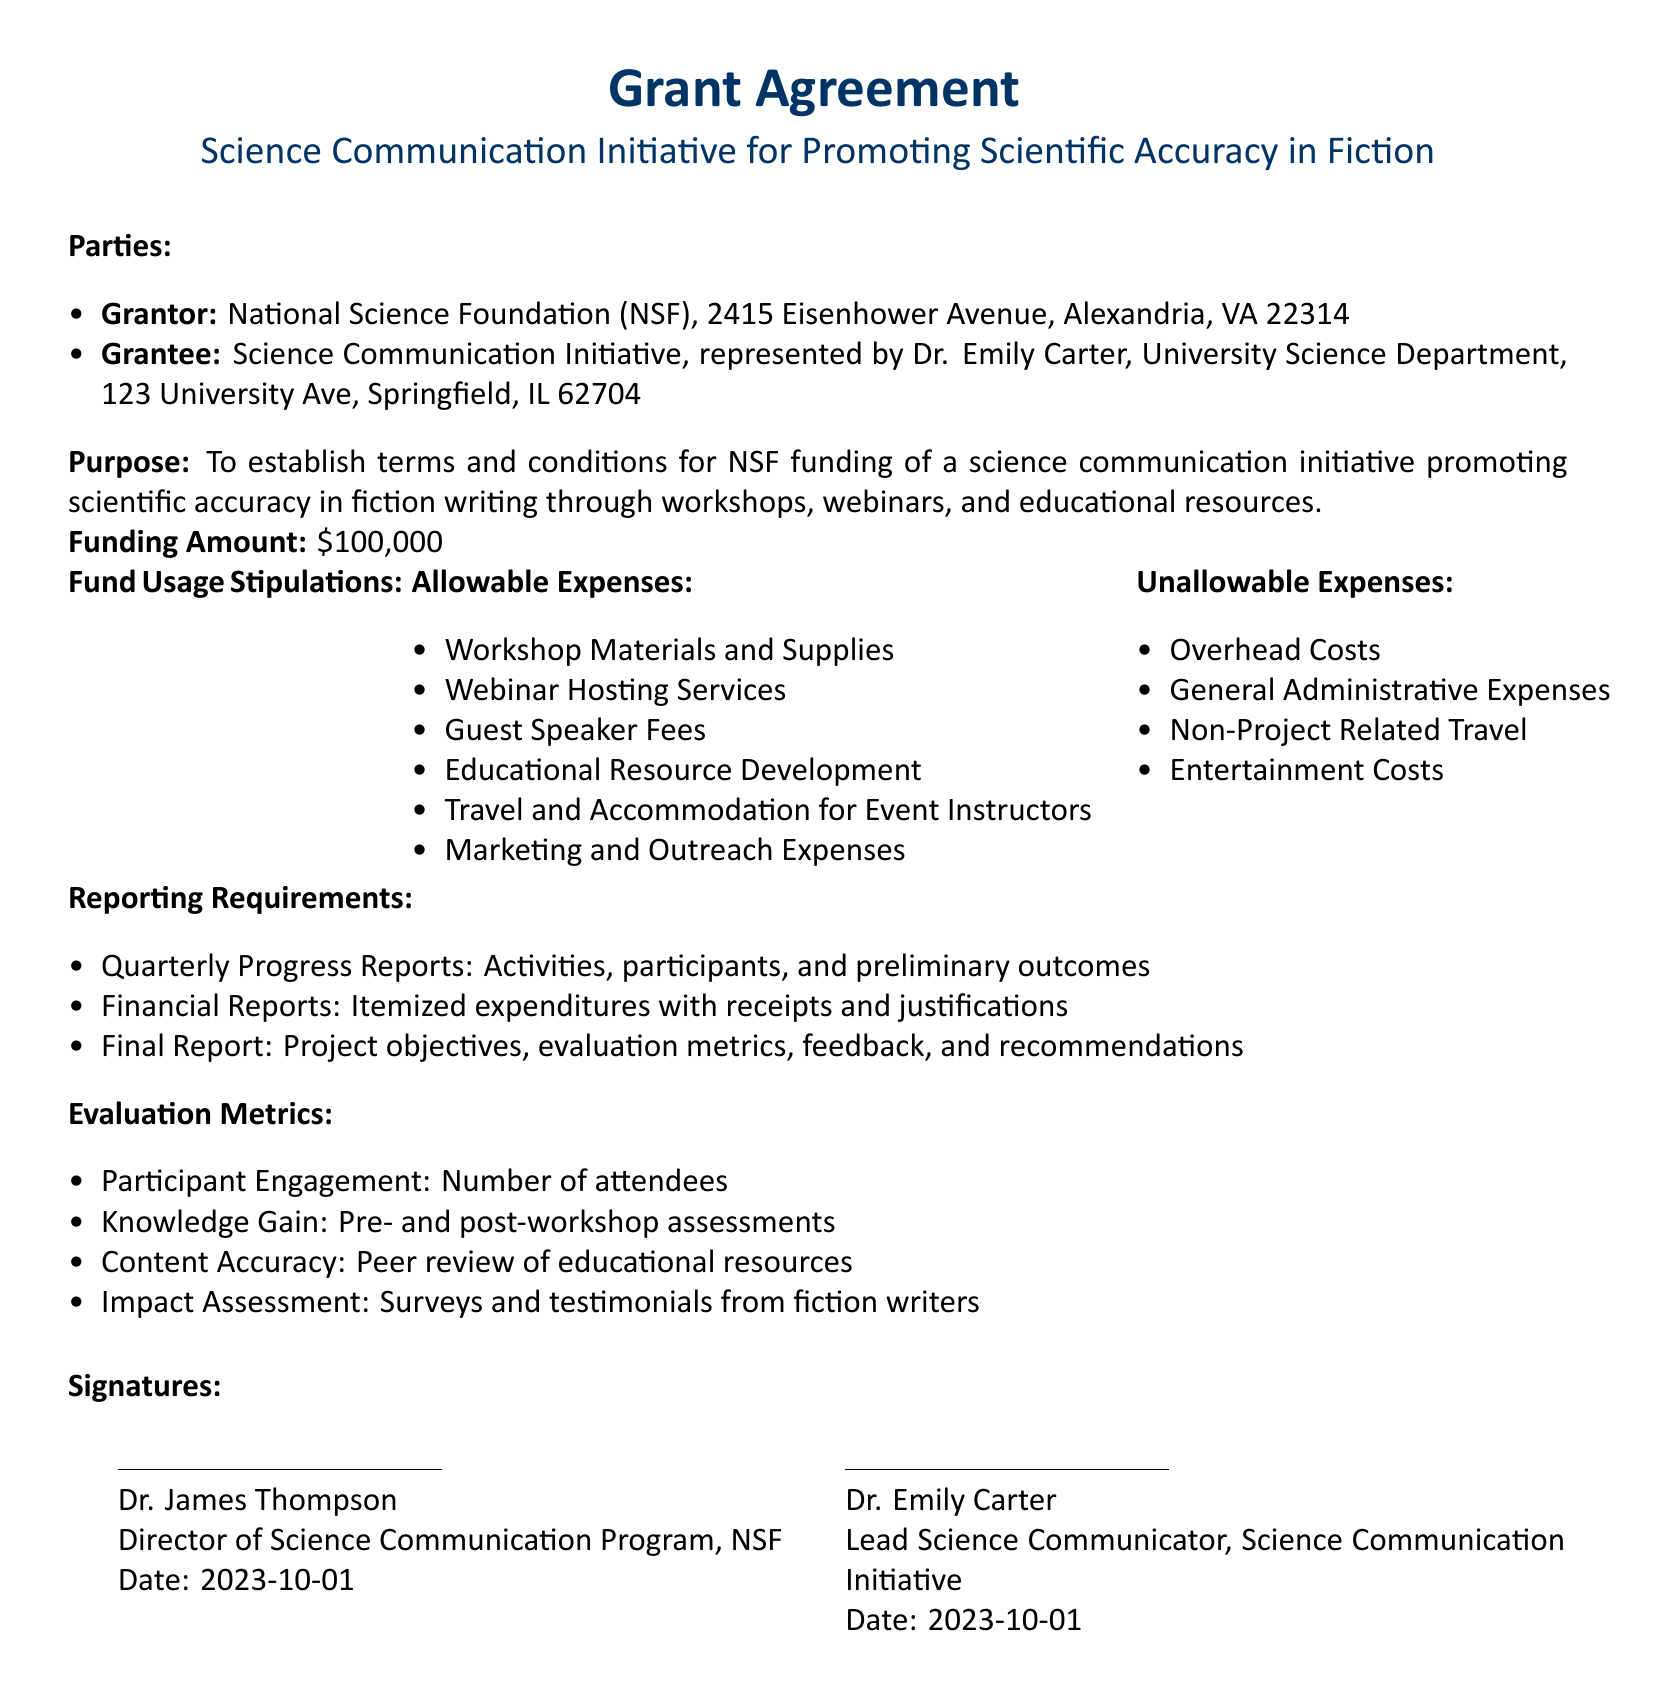What is the funding amount? The funding amount is specified in the document as the total allocated for the initiative.
Answer: $100,000 Who is the grantor? The grantor is identified in the document under the parties section, as the organization providing the funding.
Answer: National Science Foundation (NSF) What is required in the final report? The final report must include several components as stated under the reporting requirements section.
Answer: Project objectives, evaluation metrics, feedback, and recommendations What are allowable expenses? Allowable expenses are listed in the document and define what the funds can be used for.
Answer: Workshop Materials and Supplies How many evaluation metrics are listed? The evaluation metrics section outlines specific ways to assess the project's effectiveness.
Answer: Four What is the purpose of the grant agreement? The purpose is clearly stated at the beginning of the document and defines the goal of the funding.
Answer: To establish terms and conditions for NSF funding of a science communication initiative What date was the agreement signed? The date of signature is provided on the signature lines of the document.
Answer: 2023-10-01 Who represents the grantee? The grantee's representative is detailed in the document, indicating who will lead the initiative.
Answer: Dr. Emily Carter 